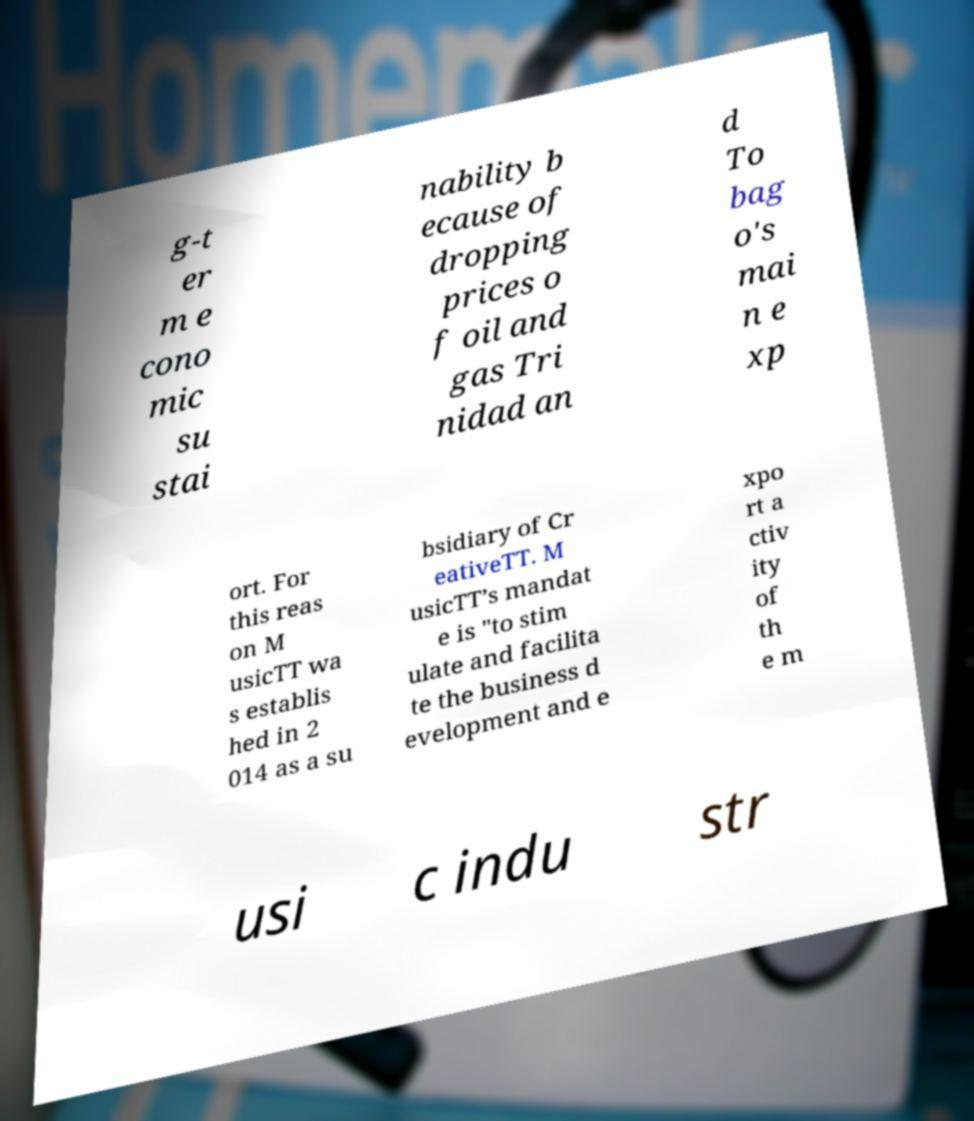I need the written content from this picture converted into text. Can you do that? g-t er m e cono mic su stai nability b ecause of dropping prices o f oil and gas Tri nidad an d To bag o's mai n e xp ort. For this reas on M usicTT wa s establis hed in 2 014 as a su bsidiary of Cr eativeTT. M usicTT’s mandat e is "to stim ulate and facilita te the business d evelopment and e xpo rt a ctiv ity of th e m usi c indu str 